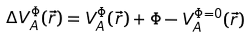Convert formula to latex. <formula><loc_0><loc_0><loc_500><loc_500>\Delta V ^ { \Phi } _ { A } ( \vec { r } ) = V ^ { \Phi } _ { A } ( \vec { r } ) + \Phi - V ^ { \Phi = 0 } _ { A } ( \vec { r } )</formula> 